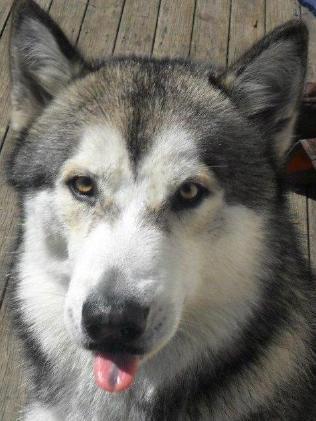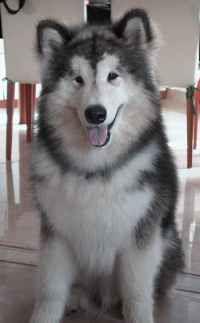The first image is the image on the left, the second image is the image on the right. For the images shown, is this caption "there are two huskies with their tongue sticking out in the image pair" true? Answer yes or no. Yes. 